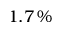Convert formula to latex. <formula><loc_0><loc_0><loc_500><loc_500>1 . 7 \, \%</formula> 